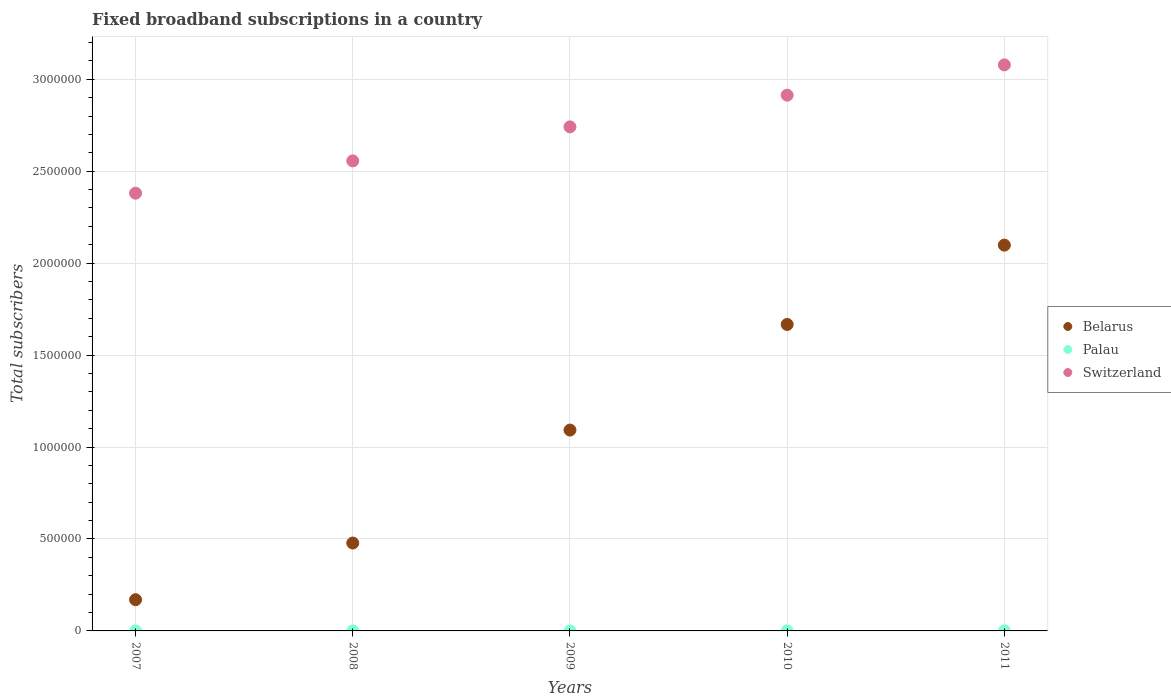Is the number of dotlines equal to the number of legend labels?
Your answer should be compact. Yes. What is the number of broadband subscriptions in Belarus in 2007?
Provide a short and direct response. 1.70e+05. Across all years, what is the maximum number of broadband subscriptions in Switzerland?
Your answer should be compact. 3.08e+06. Across all years, what is the minimum number of broadband subscriptions in Switzerland?
Your answer should be very brief. 2.38e+06. In which year was the number of broadband subscriptions in Belarus minimum?
Provide a succinct answer. 2007. What is the total number of broadband subscriptions in Switzerland in the graph?
Ensure brevity in your answer.  1.37e+07. What is the difference between the number of broadband subscriptions in Switzerland in 2008 and that in 2009?
Your answer should be very brief. -1.85e+05. What is the difference between the number of broadband subscriptions in Switzerland in 2011 and the number of broadband subscriptions in Belarus in 2007?
Provide a short and direct response. 2.91e+06. What is the average number of broadband subscriptions in Palau per year?
Your answer should be very brief. 222.2. In the year 2010, what is the difference between the number of broadband subscriptions in Belarus and number of broadband subscriptions in Switzerland?
Give a very brief answer. -1.25e+06. In how many years, is the number of broadband subscriptions in Belarus greater than 2000000?
Offer a very short reply. 1. What is the ratio of the number of broadband subscriptions in Palau in 2008 to that in 2009?
Offer a terse response. 0.78. Is the number of broadband subscriptions in Belarus in 2008 less than that in 2010?
Offer a very short reply. Yes. What is the difference between the highest and the second highest number of broadband subscriptions in Switzerland?
Make the answer very short. 1.65e+05. What is the difference between the highest and the lowest number of broadband subscriptions in Palau?
Your answer should be very brief. 417. In how many years, is the number of broadband subscriptions in Switzerland greater than the average number of broadband subscriptions in Switzerland taken over all years?
Make the answer very short. 3. Is the sum of the number of broadband subscriptions in Switzerland in 2010 and 2011 greater than the maximum number of broadband subscriptions in Belarus across all years?
Provide a succinct answer. Yes. Is it the case that in every year, the sum of the number of broadband subscriptions in Switzerland and number of broadband subscriptions in Palau  is greater than the number of broadband subscriptions in Belarus?
Provide a succinct answer. Yes. Does the number of broadband subscriptions in Belarus monotonically increase over the years?
Provide a succinct answer. Yes. Is the number of broadband subscriptions in Belarus strictly greater than the number of broadband subscriptions in Palau over the years?
Keep it short and to the point. Yes. How many years are there in the graph?
Ensure brevity in your answer.  5. Are the values on the major ticks of Y-axis written in scientific E-notation?
Make the answer very short. No. Does the graph contain grids?
Ensure brevity in your answer.  Yes. Where does the legend appear in the graph?
Your answer should be very brief. Center right. How many legend labels are there?
Keep it short and to the point. 3. How are the legend labels stacked?
Offer a very short reply. Vertical. What is the title of the graph?
Your answer should be very brief. Fixed broadband subscriptions in a country. What is the label or title of the Y-axis?
Your answer should be compact. Total subscribers. What is the Total subscribers of Belarus in 2007?
Provide a succinct answer. 1.70e+05. What is the Total subscribers in Palau in 2007?
Provide a succinct answer. 101. What is the Total subscribers in Switzerland in 2007?
Give a very brief answer. 2.38e+06. What is the Total subscribers in Belarus in 2008?
Ensure brevity in your answer.  4.78e+05. What is the Total subscribers of Palau in 2008?
Ensure brevity in your answer.  111. What is the Total subscribers in Switzerland in 2008?
Offer a very short reply. 2.56e+06. What is the Total subscribers in Belarus in 2009?
Your answer should be compact. 1.09e+06. What is the Total subscribers in Palau in 2009?
Your response must be concise. 142. What is the Total subscribers in Switzerland in 2009?
Your answer should be very brief. 2.74e+06. What is the Total subscribers of Belarus in 2010?
Your response must be concise. 1.67e+06. What is the Total subscribers in Palau in 2010?
Offer a very short reply. 239. What is the Total subscribers in Switzerland in 2010?
Provide a short and direct response. 2.91e+06. What is the Total subscribers in Belarus in 2011?
Your response must be concise. 2.10e+06. What is the Total subscribers in Palau in 2011?
Offer a terse response. 518. What is the Total subscribers in Switzerland in 2011?
Make the answer very short. 3.08e+06. Across all years, what is the maximum Total subscribers in Belarus?
Make the answer very short. 2.10e+06. Across all years, what is the maximum Total subscribers of Palau?
Keep it short and to the point. 518. Across all years, what is the maximum Total subscribers of Switzerland?
Offer a very short reply. 3.08e+06. Across all years, what is the minimum Total subscribers in Belarus?
Your answer should be very brief. 1.70e+05. Across all years, what is the minimum Total subscribers of Palau?
Make the answer very short. 101. Across all years, what is the minimum Total subscribers of Switzerland?
Make the answer very short. 2.38e+06. What is the total Total subscribers in Belarus in the graph?
Offer a terse response. 5.50e+06. What is the total Total subscribers in Palau in the graph?
Give a very brief answer. 1111. What is the total Total subscribers of Switzerland in the graph?
Offer a very short reply. 1.37e+07. What is the difference between the Total subscribers in Belarus in 2007 and that in 2008?
Provide a short and direct response. -3.08e+05. What is the difference between the Total subscribers in Palau in 2007 and that in 2008?
Keep it short and to the point. -10. What is the difference between the Total subscribers in Switzerland in 2007 and that in 2008?
Offer a very short reply. -1.76e+05. What is the difference between the Total subscribers in Belarus in 2007 and that in 2009?
Offer a terse response. -9.22e+05. What is the difference between the Total subscribers of Palau in 2007 and that in 2009?
Give a very brief answer. -41. What is the difference between the Total subscribers of Switzerland in 2007 and that in 2009?
Give a very brief answer. -3.61e+05. What is the difference between the Total subscribers of Belarus in 2007 and that in 2010?
Ensure brevity in your answer.  -1.50e+06. What is the difference between the Total subscribers in Palau in 2007 and that in 2010?
Make the answer very short. -138. What is the difference between the Total subscribers in Switzerland in 2007 and that in 2010?
Offer a terse response. -5.33e+05. What is the difference between the Total subscribers of Belarus in 2007 and that in 2011?
Offer a terse response. -1.93e+06. What is the difference between the Total subscribers in Palau in 2007 and that in 2011?
Ensure brevity in your answer.  -417. What is the difference between the Total subscribers in Switzerland in 2007 and that in 2011?
Ensure brevity in your answer.  -6.98e+05. What is the difference between the Total subscribers of Belarus in 2008 and that in 2009?
Your answer should be compact. -6.14e+05. What is the difference between the Total subscribers of Palau in 2008 and that in 2009?
Your response must be concise. -31. What is the difference between the Total subscribers in Switzerland in 2008 and that in 2009?
Offer a very short reply. -1.85e+05. What is the difference between the Total subscribers of Belarus in 2008 and that in 2010?
Provide a succinct answer. -1.19e+06. What is the difference between the Total subscribers in Palau in 2008 and that in 2010?
Provide a succinct answer. -128. What is the difference between the Total subscribers in Switzerland in 2008 and that in 2010?
Provide a succinct answer. -3.57e+05. What is the difference between the Total subscribers in Belarus in 2008 and that in 2011?
Offer a very short reply. -1.62e+06. What is the difference between the Total subscribers of Palau in 2008 and that in 2011?
Ensure brevity in your answer.  -407. What is the difference between the Total subscribers in Switzerland in 2008 and that in 2011?
Your response must be concise. -5.22e+05. What is the difference between the Total subscribers in Belarus in 2009 and that in 2010?
Ensure brevity in your answer.  -5.74e+05. What is the difference between the Total subscribers in Palau in 2009 and that in 2010?
Provide a succinct answer. -97. What is the difference between the Total subscribers in Switzerland in 2009 and that in 2010?
Offer a terse response. -1.72e+05. What is the difference between the Total subscribers in Belarus in 2009 and that in 2011?
Provide a short and direct response. -1.01e+06. What is the difference between the Total subscribers in Palau in 2009 and that in 2011?
Provide a succinct answer. -376. What is the difference between the Total subscribers of Switzerland in 2009 and that in 2011?
Your response must be concise. -3.37e+05. What is the difference between the Total subscribers of Belarus in 2010 and that in 2011?
Give a very brief answer. -4.31e+05. What is the difference between the Total subscribers of Palau in 2010 and that in 2011?
Your response must be concise. -279. What is the difference between the Total subscribers in Switzerland in 2010 and that in 2011?
Provide a short and direct response. -1.65e+05. What is the difference between the Total subscribers in Belarus in 2007 and the Total subscribers in Palau in 2008?
Make the answer very short. 1.70e+05. What is the difference between the Total subscribers in Belarus in 2007 and the Total subscribers in Switzerland in 2008?
Your answer should be compact. -2.39e+06. What is the difference between the Total subscribers in Palau in 2007 and the Total subscribers in Switzerland in 2008?
Your answer should be compact. -2.56e+06. What is the difference between the Total subscribers in Belarus in 2007 and the Total subscribers in Palau in 2009?
Keep it short and to the point. 1.70e+05. What is the difference between the Total subscribers of Belarus in 2007 and the Total subscribers of Switzerland in 2009?
Offer a terse response. -2.57e+06. What is the difference between the Total subscribers of Palau in 2007 and the Total subscribers of Switzerland in 2009?
Ensure brevity in your answer.  -2.74e+06. What is the difference between the Total subscribers in Belarus in 2007 and the Total subscribers in Palau in 2010?
Ensure brevity in your answer.  1.70e+05. What is the difference between the Total subscribers of Belarus in 2007 and the Total subscribers of Switzerland in 2010?
Provide a short and direct response. -2.74e+06. What is the difference between the Total subscribers in Palau in 2007 and the Total subscribers in Switzerland in 2010?
Keep it short and to the point. -2.91e+06. What is the difference between the Total subscribers of Belarus in 2007 and the Total subscribers of Palau in 2011?
Your answer should be compact. 1.69e+05. What is the difference between the Total subscribers of Belarus in 2007 and the Total subscribers of Switzerland in 2011?
Keep it short and to the point. -2.91e+06. What is the difference between the Total subscribers of Palau in 2007 and the Total subscribers of Switzerland in 2011?
Your response must be concise. -3.08e+06. What is the difference between the Total subscribers of Belarus in 2008 and the Total subscribers of Palau in 2009?
Offer a terse response. 4.78e+05. What is the difference between the Total subscribers of Belarus in 2008 and the Total subscribers of Switzerland in 2009?
Keep it short and to the point. -2.26e+06. What is the difference between the Total subscribers of Palau in 2008 and the Total subscribers of Switzerland in 2009?
Give a very brief answer. -2.74e+06. What is the difference between the Total subscribers in Belarus in 2008 and the Total subscribers in Palau in 2010?
Provide a succinct answer. 4.78e+05. What is the difference between the Total subscribers in Belarus in 2008 and the Total subscribers in Switzerland in 2010?
Your answer should be very brief. -2.44e+06. What is the difference between the Total subscribers in Palau in 2008 and the Total subscribers in Switzerland in 2010?
Keep it short and to the point. -2.91e+06. What is the difference between the Total subscribers of Belarus in 2008 and the Total subscribers of Palau in 2011?
Ensure brevity in your answer.  4.77e+05. What is the difference between the Total subscribers in Belarus in 2008 and the Total subscribers in Switzerland in 2011?
Provide a succinct answer. -2.60e+06. What is the difference between the Total subscribers of Palau in 2008 and the Total subscribers of Switzerland in 2011?
Keep it short and to the point. -3.08e+06. What is the difference between the Total subscribers in Belarus in 2009 and the Total subscribers in Palau in 2010?
Make the answer very short. 1.09e+06. What is the difference between the Total subscribers of Belarus in 2009 and the Total subscribers of Switzerland in 2010?
Ensure brevity in your answer.  -1.82e+06. What is the difference between the Total subscribers in Palau in 2009 and the Total subscribers in Switzerland in 2010?
Provide a succinct answer. -2.91e+06. What is the difference between the Total subscribers of Belarus in 2009 and the Total subscribers of Palau in 2011?
Your response must be concise. 1.09e+06. What is the difference between the Total subscribers of Belarus in 2009 and the Total subscribers of Switzerland in 2011?
Your answer should be compact. -1.99e+06. What is the difference between the Total subscribers of Palau in 2009 and the Total subscribers of Switzerland in 2011?
Offer a terse response. -3.08e+06. What is the difference between the Total subscribers of Belarus in 2010 and the Total subscribers of Palau in 2011?
Your answer should be compact. 1.67e+06. What is the difference between the Total subscribers of Belarus in 2010 and the Total subscribers of Switzerland in 2011?
Offer a terse response. -1.41e+06. What is the difference between the Total subscribers of Palau in 2010 and the Total subscribers of Switzerland in 2011?
Keep it short and to the point. -3.08e+06. What is the average Total subscribers in Belarus per year?
Provide a succinct answer. 1.10e+06. What is the average Total subscribers of Palau per year?
Your response must be concise. 222.2. What is the average Total subscribers of Switzerland per year?
Ensure brevity in your answer.  2.73e+06. In the year 2007, what is the difference between the Total subscribers in Belarus and Total subscribers in Palau?
Keep it short and to the point. 1.70e+05. In the year 2007, what is the difference between the Total subscribers in Belarus and Total subscribers in Switzerland?
Your answer should be very brief. -2.21e+06. In the year 2007, what is the difference between the Total subscribers in Palau and Total subscribers in Switzerland?
Offer a very short reply. -2.38e+06. In the year 2008, what is the difference between the Total subscribers of Belarus and Total subscribers of Palau?
Keep it short and to the point. 4.78e+05. In the year 2008, what is the difference between the Total subscribers of Belarus and Total subscribers of Switzerland?
Your response must be concise. -2.08e+06. In the year 2008, what is the difference between the Total subscribers in Palau and Total subscribers in Switzerland?
Your answer should be very brief. -2.56e+06. In the year 2009, what is the difference between the Total subscribers in Belarus and Total subscribers in Palau?
Keep it short and to the point. 1.09e+06. In the year 2009, what is the difference between the Total subscribers of Belarus and Total subscribers of Switzerland?
Your answer should be very brief. -1.65e+06. In the year 2009, what is the difference between the Total subscribers in Palau and Total subscribers in Switzerland?
Ensure brevity in your answer.  -2.74e+06. In the year 2010, what is the difference between the Total subscribers in Belarus and Total subscribers in Palau?
Keep it short and to the point. 1.67e+06. In the year 2010, what is the difference between the Total subscribers of Belarus and Total subscribers of Switzerland?
Your answer should be very brief. -1.25e+06. In the year 2010, what is the difference between the Total subscribers of Palau and Total subscribers of Switzerland?
Make the answer very short. -2.91e+06. In the year 2011, what is the difference between the Total subscribers of Belarus and Total subscribers of Palau?
Offer a very short reply. 2.10e+06. In the year 2011, what is the difference between the Total subscribers of Belarus and Total subscribers of Switzerland?
Offer a terse response. -9.80e+05. In the year 2011, what is the difference between the Total subscribers of Palau and Total subscribers of Switzerland?
Ensure brevity in your answer.  -3.08e+06. What is the ratio of the Total subscribers in Belarus in 2007 to that in 2008?
Provide a succinct answer. 0.36. What is the ratio of the Total subscribers in Palau in 2007 to that in 2008?
Offer a terse response. 0.91. What is the ratio of the Total subscribers of Switzerland in 2007 to that in 2008?
Keep it short and to the point. 0.93. What is the ratio of the Total subscribers in Belarus in 2007 to that in 2009?
Make the answer very short. 0.16. What is the ratio of the Total subscribers in Palau in 2007 to that in 2009?
Give a very brief answer. 0.71. What is the ratio of the Total subscribers in Switzerland in 2007 to that in 2009?
Your answer should be very brief. 0.87. What is the ratio of the Total subscribers in Belarus in 2007 to that in 2010?
Provide a succinct answer. 0.1. What is the ratio of the Total subscribers in Palau in 2007 to that in 2010?
Keep it short and to the point. 0.42. What is the ratio of the Total subscribers in Switzerland in 2007 to that in 2010?
Provide a short and direct response. 0.82. What is the ratio of the Total subscribers of Belarus in 2007 to that in 2011?
Keep it short and to the point. 0.08. What is the ratio of the Total subscribers of Palau in 2007 to that in 2011?
Provide a succinct answer. 0.2. What is the ratio of the Total subscribers of Switzerland in 2007 to that in 2011?
Offer a very short reply. 0.77. What is the ratio of the Total subscribers in Belarus in 2008 to that in 2009?
Offer a very short reply. 0.44. What is the ratio of the Total subscribers in Palau in 2008 to that in 2009?
Ensure brevity in your answer.  0.78. What is the ratio of the Total subscribers of Switzerland in 2008 to that in 2009?
Provide a short and direct response. 0.93. What is the ratio of the Total subscribers of Belarus in 2008 to that in 2010?
Provide a succinct answer. 0.29. What is the ratio of the Total subscribers of Palau in 2008 to that in 2010?
Make the answer very short. 0.46. What is the ratio of the Total subscribers of Switzerland in 2008 to that in 2010?
Your response must be concise. 0.88. What is the ratio of the Total subscribers of Belarus in 2008 to that in 2011?
Provide a succinct answer. 0.23. What is the ratio of the Total subscribers of Palau in 2008 to that in 2011?
Keep it short and to the point. 0.21. What is the ratio of the Total subscribers in Switzerland in 2008 to that in 2011?
Your response must be concise. 0.83. What is the ratio of the Total subscribers in Belarus in 2009 to that in 2010?
Provide a short and direct response. 0.66. What is the ratio of the Total subscribers of Palau in 2009 to that in 2010?
Keep it short and to the point. 0.59. What is the ratio of the Total subscribers of Switzerland in 2009 to that in 2010?
Ensure brevity in your answer.  0.94. What is the ratio of the Total subscribers in Belarus in 2009 to that in 2011?
Make the answer very short. 0.52. What is the ratio of the Total subscribers in Palau in 2009 to that in 2011?
Offer a very short reply. 0.27. What is the ratio of the Total subscribers in Switzerland in 2009 to that in 2011?
Provide a succinct answer. 0.89. What is the ratio of the Total subscribers in Belarus in 2010 to that in 2011?
Provide a short and direct response. 0.79. What is the ratio of the Total subscribers of Palau in 2010 to that in 2011?
Make the answer very short. 0.46. What is the ratio of the Total subscribers of Switzerland in 2010 to that in 2011?
Provide a short and direct response. 0.95. What is the difference between the highest and the second highest Total subscribers in Belarus?
Your response must be concise. 4.31e+05. What is the difference between the highest and the second highest Total subscribers in Palau?
Offer a very short reply. 279. What is the difference between the highest and the second highest Total subscribers in Switzerland?
Ensure brevity in your answer.  1.65e+05. What is the difference between the highest and the lowest Total subscribers in Belarus?
Give a very brief answer. 1.93e+06. What is the difference between the highest and the lowest Total subscribers in Palau?
Ensure brevity in your answer.  417. What is the difference between the highest and the lowest Total subscribers of Switzerland?
Keep it short and to the point. 6.98e+05. 